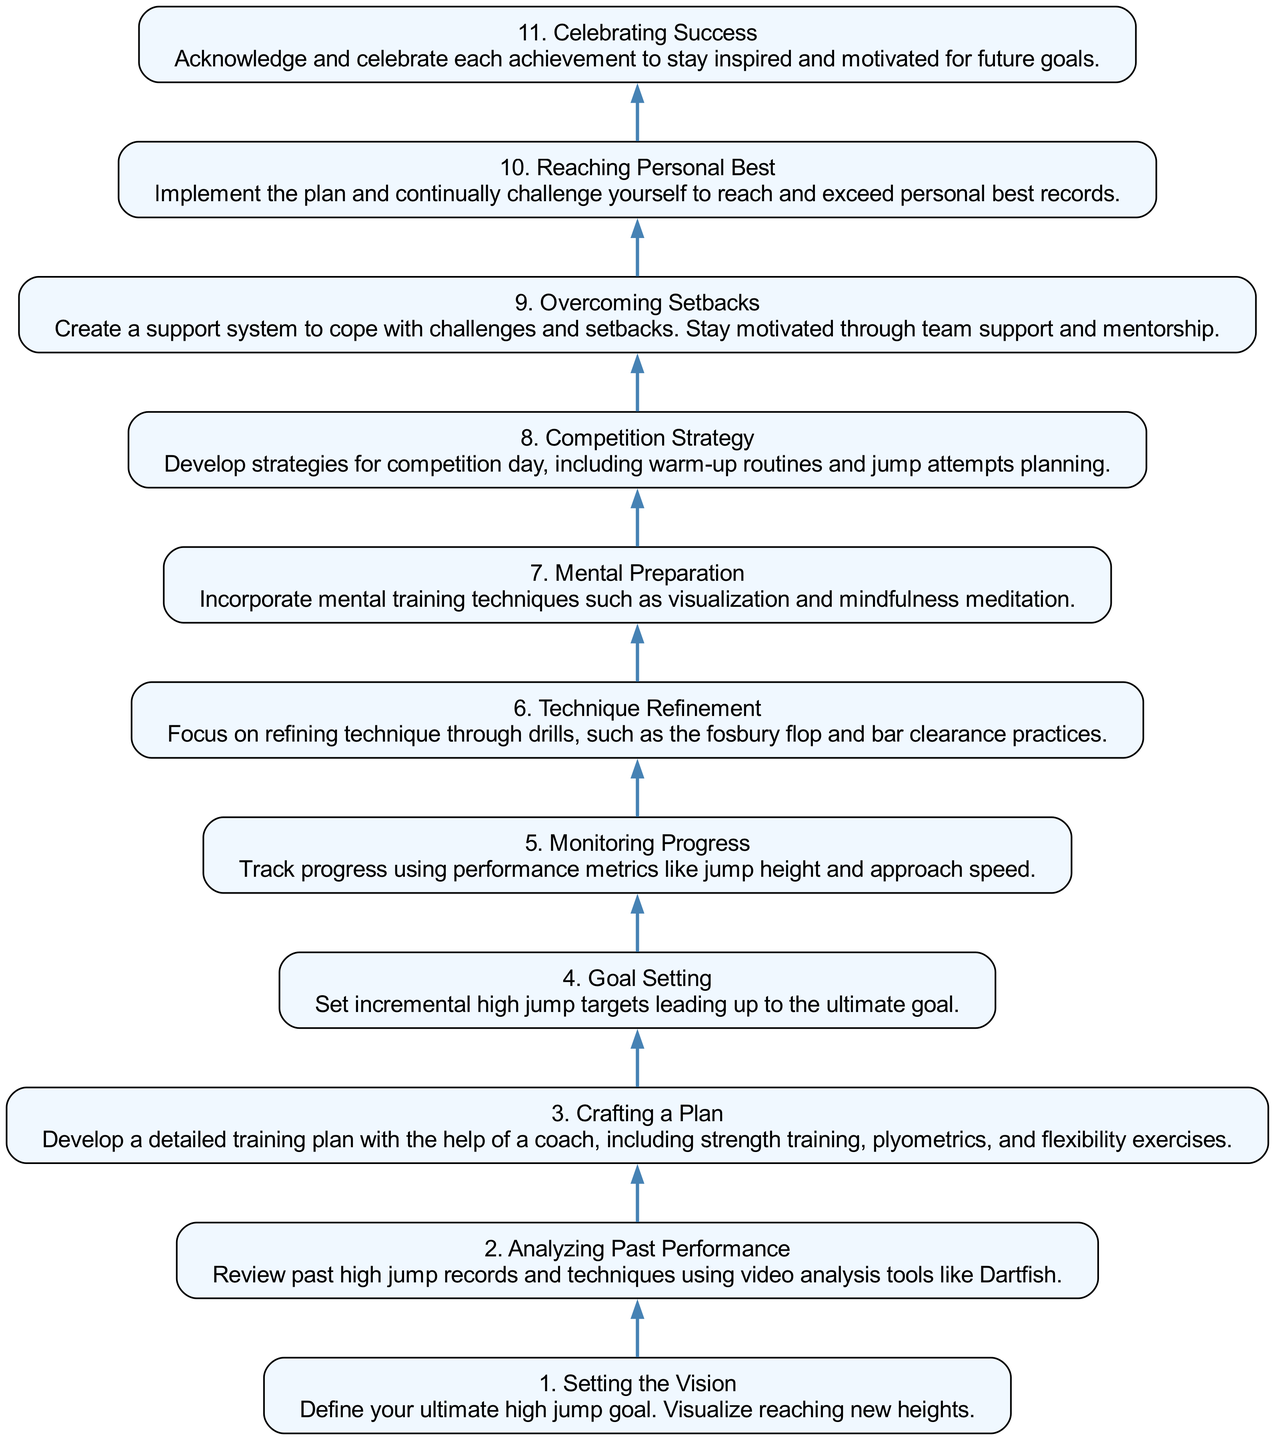What is the first step in the journey? The first step in the journey is labeled "1. Setting the Vision," which is where the ultimate high jump goal is defined.
Answer: 1. Setting the Vision How many total steps are in the journey? By counting the nodes listed in the diagram, we see there are 11 distinct steps from "Setting the Vision" to "Celebrating Success."
Answer: 11 What is the goal of the step labeled "4. Goal Setting"? In "4. Goal Setting," the aim is to set incremental high jump targets leading up to the ultimate goal.
Answer: Set incremental high jump targets Which step directly follows "Mental Preparation"? The step that directly follows "Mental Preparation" is "Competition Strategy," indicating the progression in the journey from mental readiness to planning for competition.
Answer: Competition Strategy What type of training is included in "3. Crafting a Plan"? The training types included in "3. Crafting a Plan" are strength training, plyometrics, and flexibility exercises, showing a comprehensive approach to physical fitness.
Answer: Strength training, plyometrics, and flexibility exercises Which step includes coping strategies for challenges? The step that involves coping strategies is "9. Overcoming Setbacks," emphasizing the importance of support systems and motivation in the face of setbacks.
Answer: Overcoming Setbacks What is the final step of the journey? The last step of the journey outlined in the diagram is "11. Celebrating Success," which focuses on acknowledging achievements.
Answer: 11. Celebrating Success What is the purpose of "6. Technique Refinement"? The purpose of "6. Technique Refinement" is to refine jumping techniques through specific drills to enhance performance in high jump events.
Answer: Refine technique through drills Which steps involve progress monitoring before celebrating success? The steps that involve progress monitoring before reaching the final celebration are "5. Monitoring Progress" and "10. Reaching Personal Best," which both aim to ensure the athlete is on track and improving.
Answer: Monitoring Progress and Reaching Personal Best 